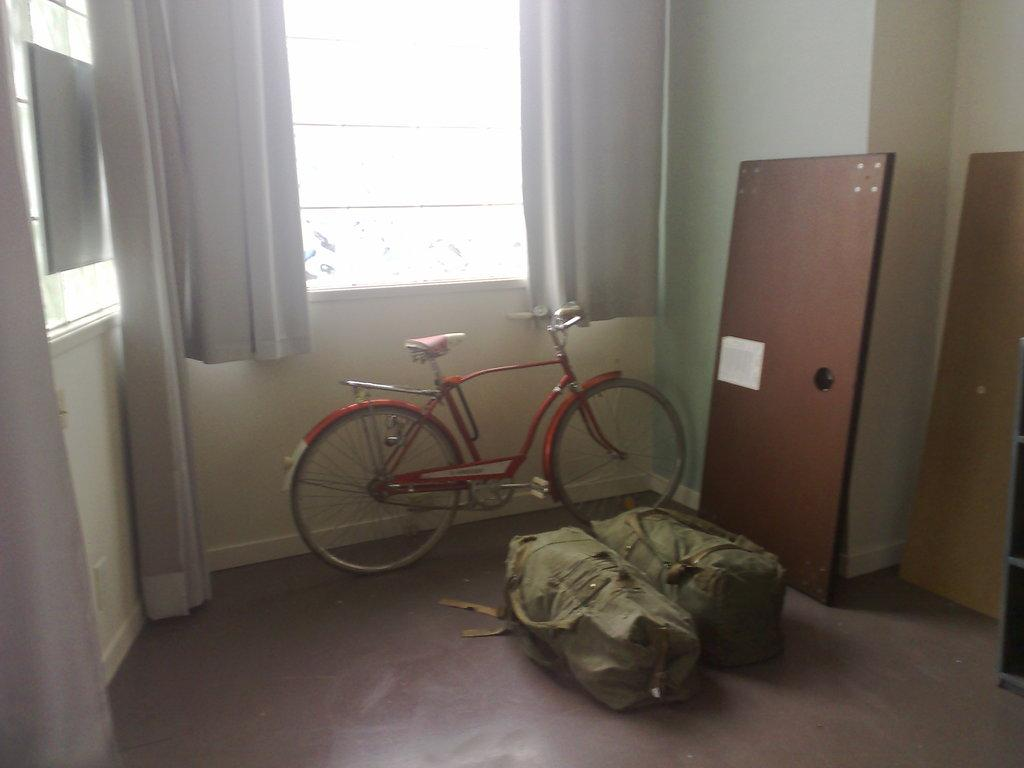What type of vehicle is in the image? There is a red cycle in the image. What else can be seen in the image besides the cycle? There are two luggage bags in the image. Is there any architectural feature visible in the image? Yes, there is a window in the image. Can you see a frog sitting on the table in the image? There is no table or frog present in the image. 